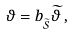Convert formula to latex. <formula><loc_0><loc_0><loc_500><loc_500>\vartheta = b _ { _ { \widetilde { \mathcal { S } } } } \widetilde { \vartheta } \, ,</formula> 